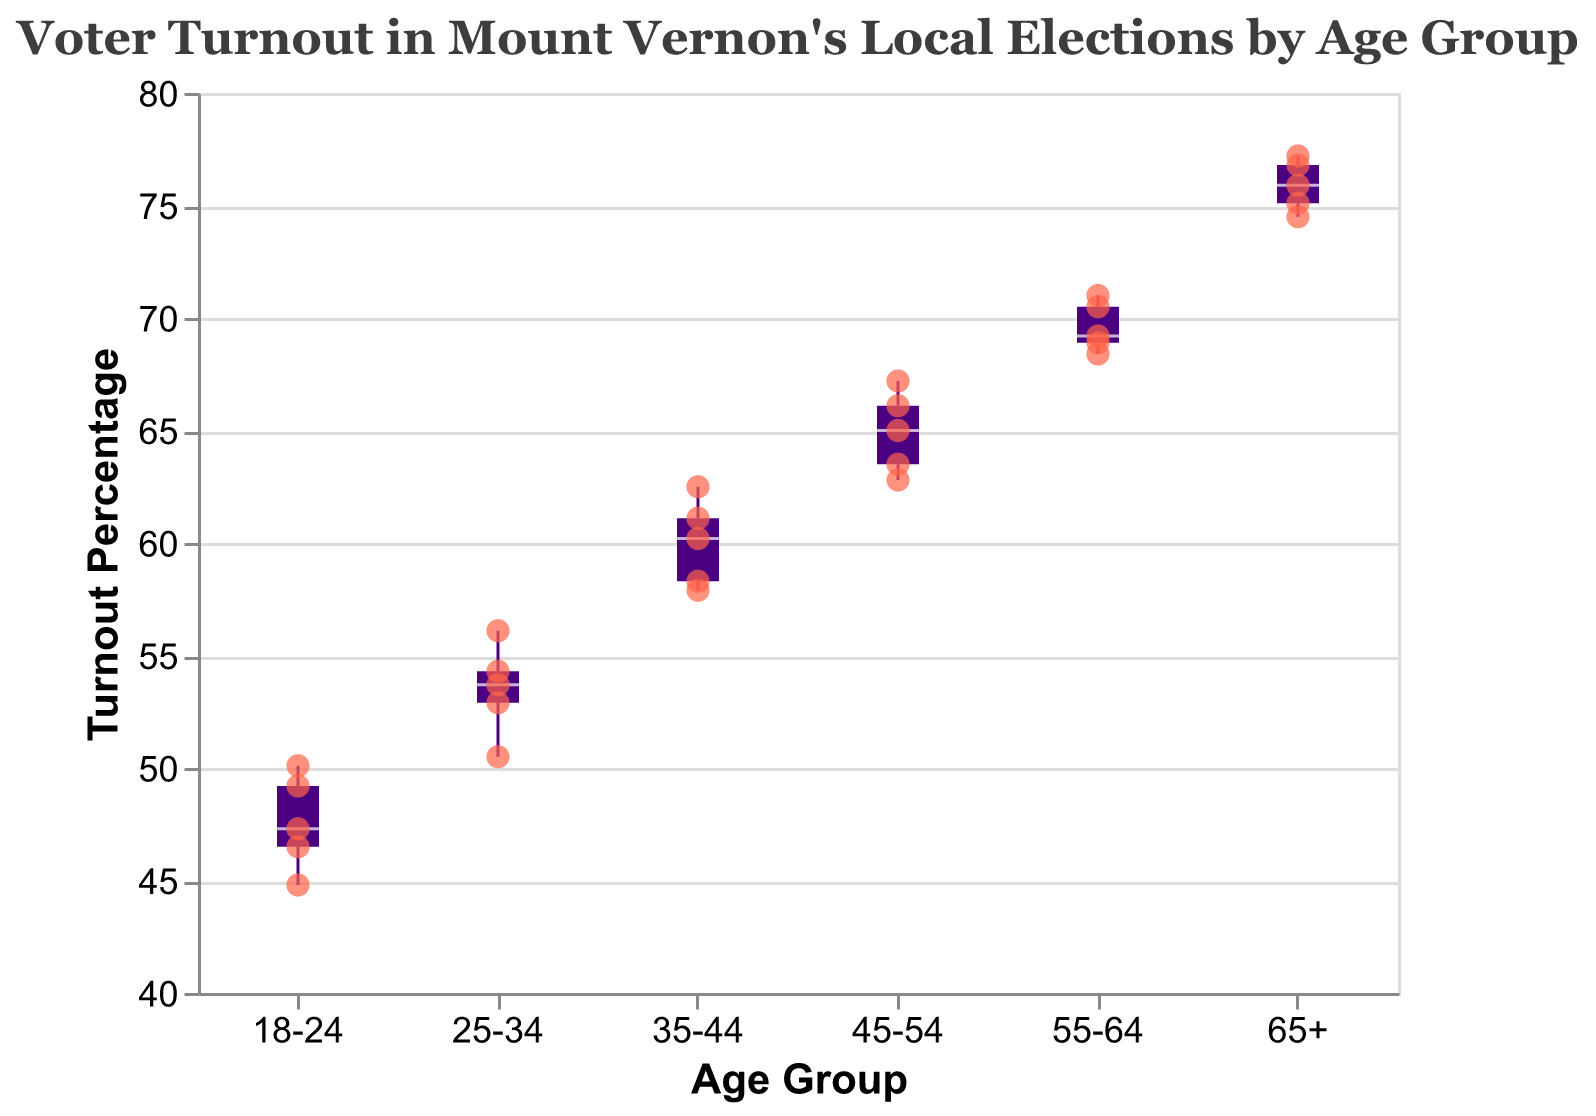What is the title of the figure? The title of a figure is usually displayed prominently at the top. Here, it reads "Voter Turnout in Mount Vernon's Local Elections by Age Group".
Answer: Voter Turnout in Mount Vernon's Local Elections by Age Group Which age group shows the highest voter turnout? To identify the highest turnout, look for the rightmost box and its median. The "65+" age group exhibits the highest median voter turnout.
Answer: 65+ What is the median turnout percentage for the 25-34 age group? The median is typically marked with a distinct line in the box plot. For the 25-34 age group, it is the white line inside the box, which is approximately 53%.
Answer: 53% How does the turnout percentage for the 45-54 age group compare to the 35-44 age group? Compare the medians of the two age groups. The median for 45-54 is higher than that for 35-44, indicating greater voter engagement among 45-54-year-olds.
Answer: 45-54 has a higher turnout For the age group 18-24, what is the range of the turnout percentage? The range is determined by the minimum and maximum points in the box plot. For the 18-24 age group, it spans from 44.8% to 50.1%.
Answer: 44.8% to 50.1% Which age group has the largest variability in voter turnout? Variability in a box plot is indicated by the length of the box and the range of the whiskers. The "45-54" age group shows the largest spread, suggesting the greatest variability.
Answer: 45-54 Are there any outliers in the data? Outliers in a box plot appear as individual points outside the whiskers. In this figure, there are no points clearly outside the whisker range, so no outliers are present.
Answer: No What is the minimum voter turnout percentage for the 55-64 age group? The minimum value in a box plot is indicated by the bottom whisker. For the 55-64 age group, it is approximately 68.4%.
Answer: 68.4% Which age group shows less than 50% voter turnout in the scatter points? Identify the scatter points below the 50% mark. Only the 18-24 age group has points that fall below this threshold.
Answer: 18-24 